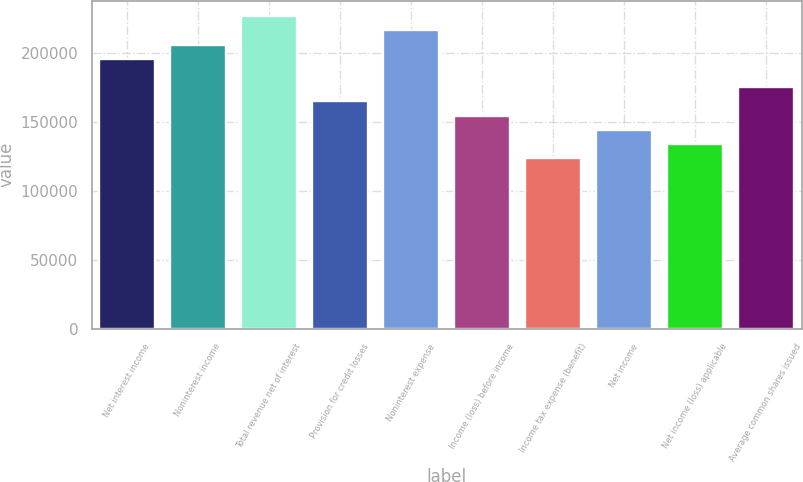<chart> <loc_0><loc_0><loc_500><loc_500><bar_chart><fcel>Net interest income<fcel>Noninterest income<fcel>Total revenue net of interest<fcel>Provision for credit losses<fcel>Noninterest expense<fcel>Income (loss) before income<fcel>Income tax expense (benefit)<fcel>Net income<fcel>Net income (loss) applicable<fcel>Average common shares issued<nl><fcel>195934<fcel>206246<fcel>226871<fcel>164997<fcel>216558<fcel>154685<fcel>123748<fcel>144372<fcel>134060<fcel>175309<nl></chart> 